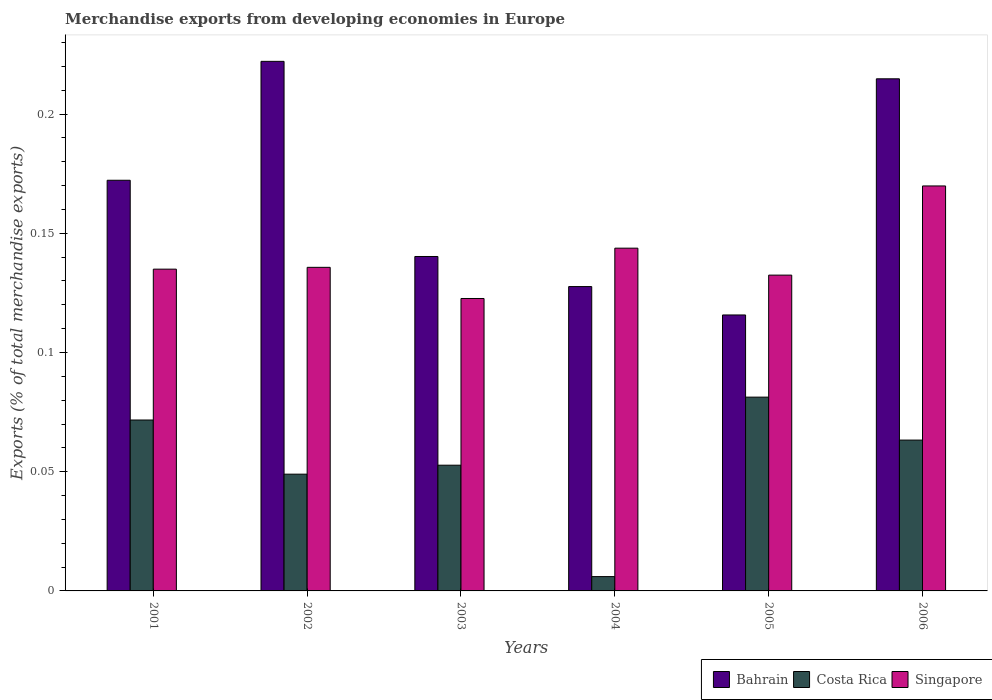How many different coloured bars are there?
Provide a succinct answer. 3. What is the label of the 5th group of bars from the left?
Provide a succinct answer. 2005. In how many cases, is the number of bars for a given year not equal to the number of legend labels?
Ensure brevity in your answer.  0. What is the percentage of total merchandise exports in Costa Rica in 2003?
Give a very brief answer. 0.05. Across all years, what is the maximum percentage of total merchandise exports in Singapore?
Give a very brief answer. 0.17. Across all years, what is the minimum percentage of total merchandise exports in Singapore?
Your answer should be compact. 0.12. In which year was the percentage of total merchandise exports in Bahrain minimum?
Ensure brevity in your answer.  2005. What is the total percentage of total merchandise exports in Costa Rica in the graph?
Your response must be concise. 0.32. What is the difference between the percentage of total merchandise exports in Costa Rica in 2003 and that in 2006?
Ensure brevity in your answer.  -0.01. What is the difference between the percentage of total merchandise exports in Costa Rica in 2005 and the percentage of total merchandise exports in Bahrain in 2004?
Provide a short and direct response. -0.05. What is the average percentage of total merchandise exports in Bahrain per year?
Provide a short and direct response. 0.17. In the year 2001, what is the difference between the percentage of total merchandise exports in Bahrain and percentage of total merchandise exports in Singapore?
Offer a terse response. 0.04. In how many years, is the percentage of total merchandise exports in Singapore greater than 0.05 %?
Offer a terse response. 6. What is the ratio of the percentage of total merchandise exports in Costa Rica in 2001 to that in 2006?
Provide a succinct answer. 1.13. Is the percentage of total merchandise exports in Bahrain in 2001 less than that in 2003?
Ensure brevity in your answer.  No. Is the difference between the percentage of total merchandise exports in Bahrain in 2003 and 2004 greater than the difference between the percentage of total merchandise exports in Singapore in 2003 and 2004?
Offer a very short reply. Yes. What is the difference between the highest and the second highest percentage of total merchandise exports in Costa Rica?
Offer a very short reply. 0.01. What is the difference between the highest and the lowest percentage of total merchandise exports in Costa Rica?
Ensure brevity in your answer.  0.08. Is the sum of the percentage of total merchandise exports in Costa Rica in 2003 and 2005 greater than the maximum percentage of total merchandise exports in Bahrain across all years?
Give a very brief answer. No. What does the 2nd bar from the left in 2003 represents?
Offer a very short reply. Costa Rica. What does the 2nd bar from the right in 2004 represents?
Your response must be concise. Costa Rica. Is it the case that in every year, the sum of the percentage of total merchandise exports in Bahrain and percentage of total merchandise exports in Singapore is greater than the percentage of total merchandise exports in Costa Rica?
Provide a short and direct response. Yes. How many bars are there?
Your response must be concise. 18. Are all the bars in the graph horizontal?
Keep it short and to the point. No. Does the graph contain any zero values?
Give a very brief answer. No. Where does the legend appear in the graph?
Your response must be concise. Bottom right. How many legend labels are there?
Ensure brevity in your answer.  3. What is the title of the graph?
Your response must be concise. Merchandise exports from developing economies in Europe. Does "Grenada" appear as one of the legend labels in the graph?
Your answer should be compact. No. What is the label or title of the X-axis?
Offer a terse response. Years. What is the label or title of the Y-axis?
Keep it short and to the point. Exports (% of total merchandise exports). What is the Exports (% of total merchandise exports) in Bahrain in 2001?
Make the answer very short. 0.17. What is the Exports (% of total merchandise exports) in Costa Rica in 2001?
Provide a succinct answer. 0.07. What is the Exports (% of total merchandise exports) of Singapore in 2001?
Provide a short and direct response. 0.13. What is the Exports (% of total merchandise exports) of Bahrain in 2002?
Your answer should be very brief. 0.22. What is the Exports (% of total merchandise exports) of Costa Rica in 2002?
Offer a terse response. 0.05. What is the Exports (% of total merchandise exports) in Singapore in 2002?
Offer a very short reply. 0.14. What is the Exports (% of total merchandise exports) in Bahrain in 2003?
Your response must be concise. 0.14. What is the Exports (% of total merchandise exports) in Costa Rica in 2003?
Offer a terse response. 0.05. What is the Exports (% of total merchandise exports) of Singapore in 2003?
Offer a terse response. 0.12. What is the Exports (% of total merchandise exports) in Bahrain in 2004?
Provide a succinct answer. 0.13. What is the Exports (% of total merchandise exports) of Costa Rica in 2004?
Ensure brevity in your answer.  0.01. What is the Exports (% of total merchandise exports) in Singapore in 2004?
Keep it short and to the point. 0.14. What is the Exports (% of total merchandise exports) in Bahrain in 2005?
Provide a short and direct response. 0.12. What is the Exports (% of total merchandise exports) of Costa Rica in 2005?
Your response must be concise. 0.08. What is the Exports (% of total merchandise exports) of Singapore in 2005?
Give a very brief answer. 0.13. What is the Exports (% of total merchandise exports) of Bahrain in 2006?
Keep it short and to the point. 0.21. What is the Exports (% of total merchandise exports) in Costa Rica in 2006?
Provide a short and direct response. 0.06. What is the Exports (% of total merchandise exports) in Singapore in 2006?
Offer a terse response. 0.17. Across all years, what is the maximum Exports (% of total merchandise exports) of Bahrain?
Ensure brevity in your answer.  0.22. Across all years, what is the maximum Exports (% of total merchandise exports) in Costa Rica?
Provide a short and direct response. 0.08. Across all years, what is the maximum Exports (% of total merchandise exports) in Singapore?
Your answer should be compact. 0.17. Across all years, what is the minimum Exports (% of total merchandise exports) of Bahrain?
Provide a short and direct response. 0.12. Across all years, what is the minimum Exports (% of total merchandise exports) of Costa Rica?
Keep it short and to the point. 0.01. Across all years, what is the minimum Exports (% of total merchandise exports) in Singapore?
Give a very brief answer. 0.12. What is the total Exports (% of total merchandise exports) in Bahrain in the graph?
Your answer should be very brief. 0.99. What is the total Exports (% of total merchandise exports) in Costa Rica in the graph?
Give a very brief answer. 0.32. What is the total Exports (% of total merchandise exports) of Singapore in the graph?
Make the answer very short. 0.84. What is the difference between the Exports (% of total merchandise exports) of Bahrain in 2001 and that in 2002?
Make the answer very short. -0.05. What is the difference between the Exports (% of total merchandise exports) of Costa Rica in 2001 and that in 2002?
Keep it short and to the point. 0.02. What is the difference between the Exports (% of total merchandise exports) of Singapore in 2001 and that in 2002?
Ensure brevity in your answer.  -0. What is the difference between the Exports (% of total merchandise exports) of Bahrain in 2001 and that in 2003?
Your answer should be very brief. 0.03. What is the difference between the Exports (% of total merchandise exports) of Costa Rica in 2001 and that in 2003?
Your answer should be very brief. 0.02. What is the difference between the Exports (% of total merchandise exports) in Singapore in 2001 and that in 2003?
Ensure brevity in your answer.  0.01. What is the difference between the Exports (% of total merchandise exports) in Bahrain in 2001 and that in 2004?
Give a very brief answer. 0.04. What is the difference between the Exports (% of total merchandise exports) of Costa Rica in 2001 and that in 2004?
Offer a terse response. 0.07. What is the difference between the Exports (% of total merchandise exports) in Singapore in 2001 and that in 2004?
Ensure brevity in your answer.  -0.01. What is the difference between the Exports (% of total merchandise exports) in Bahrain in 2001 and that in 2005?
Make the answer very short. 0.06. What is the difference between the Exports (% of total merchandise exports) in Costa Rica in 2001 and that in 2005?
Make the answer very short. -0.01. What is the difference between the Exports (% of total merchandise exports) in Singapore in 2001 and that in 2005?
Your response must be concise. 0. What is the difference between the Exports (% of total merchandise exports) in Bahrain in 2001 and that in 2006?
Give a very brief answer. -0.04. What is the difference between the Exports (% of total merchandise exports) of Costa Rica in 2001 and that in 2006?
Make the answer very short. 0.01. What is the difference between the Exports (% of total merchandise exports) of Singapore in 2001 and that in 2006?
Your answer should be compact. -0.03. What is the difference between the Exports (% of total merchandise exports) in Bahrain in 2002 and that in 2003?
Your answer should be very brief. 0.08. What is the difference between the Exports (% of total merchandise exports) of Costa Rica in 2002 and that in 2003?
Ensure brevity in your answer.  -0. What is the difference between the Exports (% of total merchandise exports) in Singapore in 2002 and that in 2003?
Your answer should be compact. 0.01. What is the difference between the Exports (% of total merchandise exports) in Bahrain in 2002 and that in 2004?
Your answer should be compact. 0.09. What is the difference between the Exports (% of total merchandise exports) of Costa Rica in 2002 and that in 2004?
Offer a very short reply. 0.04. What is the difference between the Exports (% of total merchandise exports) in Singapore in 2002 and that in 2004?
Ensure brevity in your answer.  -0.01. What is the difference between the Exports (% of total merchandise exports) of Bahrain in 2002 and that in 2005?
Your answer should be very brief. 0.11. What is the difference between the Exports (% of total merchandise exports) of Costa Rica in 2002 and that in 2005?
Your answer should be compact. -0.03. What is the difference between the Exports (% of total merchandise exports) of Singapore in 2002 and that in 2005?
Keep it short and to the point. 0. What is the difference between the Exports (% of total merchandise exports) in Bahrain in 2002 and that in 2006?
Your answer should be very brief. 0.01. What is the difference between the Exports (% of total merchandise exports) of Costa Rica in 2002 and that in 2006?
Make the answer very short. -0.01. What is the difference between the Exports (% of total merchandise exports) in Singapore in 2002 and that in 2006?
Provide a succinct answer. -0.03. What is the difference between the Exports (% of total merchandise exports) in Bahrain in 2003 and that in 2004?
Your answer should be very brief. 0.01. What is the difference between the Exports (% of total merchandise exports) of Costa Rica in 2003 and that in 2004?
Offer a terse response. 0.05. What is the difference between the Exports (% of total merchandise exports) of Singapore in 2003 and that in 2004?
Your answer should be very brief. -0.02. What is the difference between the Exports (% of total merchandise exports) of Bahrain in 2003 and that in 2005?
Provide a short and direct response. 0.02. What is the difference between the Exports (% of total merchandise exports) of Costa Rica in 2003 and that in 2005?
Your answer should be very brief. -0.03. What is the difference between the Exports (% of total merchandise exports) of Singapore in 2003 and that in 2005?
Ensure brevity in your answer.  -0.01. What is the difference between the Exports (% of total merchandise exports) of Bahrain in 2003 and that in 2006?
Give a very brief answer. -0.07. What is the difference between the Exports (% of total merchandise exports) in Costa Rica in 2003 and that in 2006?
Provide a short and direct response. -0.01. What is the difference between the Exports (% of total merchandise exports) in Singapore in 2003 and that in 2006?
Keep it short and to the point. -0.05. What is the difference between the Exports (% of total merchandise exports) of Bahrain in 2004 and that in 2005?
Provide a short and direct response. 0.01. What is the difference between the Exports (% of total merchandise exports) of Costa Rica in 2004 and that in 2005?
Provide a succinct answer. -0.08. What is the difference between the Exports (% of total merchandise exports) of Singapore in 2004 and that in 2005?
Provide a short and direct response. 0.01. What is the difference between the Exports (% of total merchandise exports) of Bahrain in 2004 and that in 2006?
Your answer should be very brief. -0.09. What is the difference between the Exports (% of total merchandise exports) in Costa Rica in 2004 and that in 2006?
Your answer should be very brief. -0.06. What is the difference between the Exports (% of total merchandise exports) of Singapore in 2004 and that in 2006?
Your answer should be very brief. -0.03. What is the difference between the Exports (% of total merchandise exports) in Bahrain in 2005 and that in 2006?
Ensure brevity in your answer.  -0.1. What is the difference between the Exports (% of total merchandise exports) in Costa Rica in 2005 and that in 2006?
Provide a short and direct response. 0.02. What is the difference between the Exports (% of total merchandise exports) in Singapore in 2005 and that in 2006?
Your response must be concise. -0.04. What is the difference between the Exports (% of total merchandise exports) in Bahrain in 2001 and the Exports (% of total merchandise exports) in Costa Rica in 2002?
Your response must be concise. 0.12. What is the difference between the Exports (% of total merchandise exports) in Bahrain in 2001 and the Exports (% of total merchandise exports) in Singapore in 2002?
Ensure brevity in your answer.  0.04. What is the difference between the Exports (% of total merchandise exports) in Costa Rica in 2001 and the Exports (% of total merchandise exports) in Singapore in 2002?
Your answer should be very brief. -0.06. What is the difference between the Exports (% of total merchandise exports) in Bahrain in 2001 and the Exports (% of total merchandise exports) in Costa Rica in 2003?
Your answer should be very brief. 0.12. What is the difference between the Exports (% of total merchandise exports) in Bahrain in 2001 and the Exports (% of total merchandise exports) in Singapore in 2003?
Give a very brief answer. 0.05. What is the difference between the Exports (% of total merchandise exports) in Costa Rica in 2001 and the Exports (% of total merchandise exports) in Singapore in 2003?
Give a very brief answer. -0.05. What is the difference between the Exports (% of total merchandise exports) of Bahrain in 2001 and the Exports (% of total merchandise exports) of Costa Rica in 2004?
Ensure brevity in your answer.  0.17. What is the difference between the Exports (% of total merchandise exports) of Bahrain in 2001 and the Exports (% of total merchandise exports) of Singapore in 2004?
Your answer should be compact. 0.03. What is the difference between the Exports (% of total merchandise exports) of Costa Rica in 2001 and the Exports (% of total merchandise exports) of Singapore in 2004?
Your answer should be compact. -0.07. What is the difference between the Exports (% of total merchandise exports) in Bahrain in 2001 and the Exports (% of total merchandise exports) in Costa Rica in 2005?
Your answer should be very brief. 0.09. What is the difference between the Exports (% of total merchandise exports) of Bahrain in 2001 and the Exports (% of total merchandise exports) of Singapore in 2005?
Make the answer very short. 0.04. What is the difference between the Exports (% of total merchandise exports) of Costa Rica in 2001 and the Exports (% of total merchandise exports) of Singapore in 2005?
Your answer should be very brief. -0.06. What is the difference between the Exports (% of total merchandise exports) of Bahrain in 2001 and the Exports (% of total merchandise exports) of Costa Rica in 2006?
Offer a very short reply. 0.11. What is the difference between the Exports (% of total merchandise exports) in Bahrain in 2001 and the Exports (% of total merchandise exports) in Singapore in 2006?
Make the answer very short. 0. What is the difference between the Exports (% of total merchandise exports) of Costa Rica in 2001 and the Exports (% of total merchandise exports) of Singapore in 2006?
Make the answer very short. -0.1. What is the difference between the Exports (% of total merchandise exports) in Bahrain in 2002 and the Exports (% of total merchandise exports) in Costa Rica in 2003?
Your answer should be compact. 0.17. What is the difference between the Exports (% of total merchandise exports) in Bahrain in 2002 and the Exports (% of total merchandise exports) in Singapore in 2003?
Make the answer very short. 0.1. What is the difference between the Exports (% of total merchandise exports) in Costa Rica in 2002 and the Exports (% of total merchandise exports) in Singapore in 2003?
Keep it short and to the point. -0.07. What is the difference between the Exports (% of total merchandise exports) in Bahrain in 2002 and the Exports (% of total merchandise exports) in Costa Rica in 2004?
Ensure brevity in your answer.  0.22. What is the difference between the Exports (% of total merchandise exports) in Bahrain in 2002 and the Exports (% of total merchandise exports) in Singapore in 2004?
Ensure brevity in your answer.  0.08. What is the difference between the Exports (% of total merchandise exports) of Costa Rica in 2002 and the Exports (% of total merchandise exports) of Singapore in 2004?
Your response must be concise. -0.09. What is the difference between the Exports (% of total merchandise exports) of Bahrain in 2002 and the Exports (% of total merchandise exports) of Costa Rica in 2005?
Your answer should be compact. 0.14. What is the difference between the Exports (% of total merchandise exports) in Bahrain in 2002 and the Exports (% of total merchandise exports) in Singapore in 2005?
Ensure brevity in your answer.  0.09. What is the difference between the Exports (% of total merchandise exports) of Costa Rica in 2002 and the Exports (% of total merchandise exports) of Singapore in 2005?
Keep it short and to the point. -0.08. What is the difference between the Exports (% of total merchandise exports) of Bahrain in 2002 and the Exports (% of total merchandise exports) of Costa Rica in 2006?
Give a very brief answer. 0.16. What is the difference between the Exports (% of total merchandise exports) in Bahrain in 2002 and the Exports (% of total merchandise exports) in Singapore in 2006?
Your response must be concise. 0.05. What is the difference between the Exports (% of total merchandise exports) in Costa Rica in 2002 and the Exports (% of total merchandise exports) in Singapore in 2006?
Provide a short and direct response. -0.12. What is the difference between the Exports (% of total merchandise exports) in Bahrain in 2003 and the Exports (% of total merchandise exports) in Costa Rica in 2004?
Your response must be concise. 0.13. What is the difference between the Exports (% of total merchandise exports) of Bahrain in 2003 and the Exports (% of total merchandise exports) of Singapore in 2004?
Offer a terse response. -0. What is the difference between the Exports (% of total merchandise exports) of Costa Rica in 2003 and the Exports (% of total merchandise exports) of Singapore in 2004?
Your answer should be compact. -0.09. What is the difference between the Exports (% of total merchandise exports) of Bahrain in 2003 and the Exports (% of total merchandise exports) of Costa Rica in 2005?
Keep it short and to the point. 0.06. What is the difference between the Exports (% of total merchandise exports) of Bahrain in 2003 and the Exports (% of total merchandise exports) of Singapore in 2005?
Make the answer very short. 0.01. What is the difference between the Exports (% of total merchandise exports) of Costa Rica in 2003 and the Exports (% of total merchandise exports) of Singapore in 2005?
Keep it short and to the point. -0.08. What is the difference between the Exports (% of total merchandise exports) in Bahrain in 2003 and the Exports (% of total merchandise exports) in Costa Rica in 2006?
Provide a short and direct response. 0.08. What is the difference between the Exports (% of total merchandise exports) of Bahrain in 2003 and the Exports (% of total merchandise exports) of Singapore in 2006?
Make the answer very short. -0.03. What is the difference between the Exports (% of total merchandise exports) in Costa Rica in 2003 and the Exports (% of total merchandise exports) in Singapore in 2006?
Your answer should be very brief. -0.12. What is the difference between the Exports (% of total merchandise exports) in Bahrain in 2004 and the Exports (% of total merchandise exports) in Costa Rica in 2005?
Your answer should be very brief. 0.05. What is the difference between the Exports (% of total merchandise exports) in Bahrain in 2004 and the Exports (% of total merchandise exports) in Singapore in 2005?
Ensure brevity in your answer.  -0. What is the difference between the Exports (% of total merchandise exports) in Costa Rica in 2004 and the Exports (% of total merchandise exports) in Singapore in 2005?
Your response must be concise. -0.13. What is the difference between the Exports (% of total merchandise exports) of Bahrain in 2004 and the Exports (% of total merchandise exports) of Costa Rica in 2006?
Your response must be concise. 0.06. What is the difference between the Exports (% of total merchandise exports) in Bahrain in 2004 and the Exports (% of total merchandise exports) in Singapore in 2006?
Give a very brief answer. -0.04. What is the difference between the Exports (% of total merchandise exports) of Costa Rica in 2004 and the Exports (% of total merchandise exports) of Singapore in 2006?
Make the answer very short. -0.16. What is the difference between the Exports (% of total merchandise exports) of Bahrain in 2005 and the Exports (% of total merchandise exports) of Costa Rica in 2006?
Your response must be concise. 0.05. What is the difference between the Exports (% of total merchandise exports) in Bahrain in 2005 and the Exports (% of total merchandise exports) in Singapore in 2006?
Ensure brevity in your answer.  -0.05. What is the difference between the Exports (% of total merchandise exports) of Costa Rica in 2005 and the Exports (% of total merchandise exports) of Singapore in 2006?
Keep it short and to the point. -0.09. What is the average Exports (% of total merchandise exports) in Bahrain per year?
Provide a short and direct response. 0.17. What is the average Exports (% of total merchandise exports) in Costa Rica per year?
Your response must be concise. 0.05. What is the average Exports (% of total merchandise exports) in Singapore per year?
Provide a succinct answer. 0.14. In the year 2001, what is the difference between the Exports (% of total merchandise exports) of Bahrain and Exports (% of total merchandise exports) of Costa Rica?
Provide a short and direct response. 0.1. In the year 2001, what is the difference between the Exports (% of total merchandise exports) in Bahrain and Exports (% of total merchandise exports) in Singapore?
Offer a terse response. 0.04. In the year 2001, what is the difference between the Exports (% of total merchandise exports) of Costa Rica and Exports (% of total merchandise exports) of Singapore?
Offer a very short reply. -0.06. In the year 2002, what is the difference between the Exports (% of total merchandise exports) of Bahrain and Exports (% of total merchandise exports) of Costa Rica?
Give a very brief answer. 0.17. In the year 2002, what is the difference between the Exports (% of total merchandise exports) in Bahrain and Exports (% of total merchandise exports) in Singapore?
Offer a very short reply. 0.09. In the year 2002, what is the difference between the Exports (% of total merchandise exports) in Costa Rica and Exports (% of total merchandise exports) in Singapore?
Give a very brief answer. -0.09. In the year 2003, what is the difference between the Exports (% of total merchandise exports) of Bahrain and Exports (% of total merchandise exports) of Costa Rica?
Make the answer very short. 0.09. In the year 2003, what is the difference between the Exports (% of total merchandise exports) in Bahrain and Exports (% of total merchandise exports) in Singapore?
Give a very brief answer. 0.02. In the year 2003, what is the difference between the Exports (% of total merchandise exports) in Costa Rica and Exports (% of total merchandise exports) in Singapore?
Your response must be concise. -0.07. In the year 2004, what is the difference between the Exports (% of total merchandise exports) of Bahrain and Exports (% of total merchandise exports) of Costa Rica?
Provide a succinct answer. 0.12. In the year 2004, what is the difference between the Exports (% of total merchandise exports) in Bahrain and Exports (% of total merchandise exports) in Singapore?
Keep it short and to the point. -0.02. In the year 2004, what is the difference between the Exports (% of total merchandise exports) in Costa Rica and Exports (% of total merchandise exports) in Singapore?
Give a very brief answer. -0.14. In the year 2005, what is the difference between the Exports (% of total merchandise exports) of Bahrain and Exports (% of total merchandise exports) of Costa Rica?
Provide a succinct answer. 0.03. In the year 2005, what is the difference between the Exports (% of total merchandise exports) of Bahrain and Exports (% of total merchandise exports) of Singapore?
Your answer should be very brief. -0.02. In the year 2005, what is the difference between the Exports (% of total merchandise exports) in Costa Rica and Exports (% of total merchandise exports) in Singapore?
Provide a short and direct response. -0.05. In the year 2006, what is the difference between the Exports (% of total merchandise exports) in Bahrain and Exports (% of total merchandise exports) in Costa Rica?
Your answer should be very brief. 0.15. In the year 2006, what is the difference between the Exports (% of total merchandise exports) of Bahrain and Exports (% of total merchandise exports) of Singapore?
Your response must be concise. 0.04. In the year 2006, what is the difference between the Exports (% of total merchandise exports) of Costa Rica and Exports (% of total merchandise exports) of Singapore?
Provide a succinct answer. -0.11. What is the ratio of the Exports (% of total merchandise exports) of Bahrain in 2001 to that in 2002?
Your answer should be very brief. 0.78. What is the ratio of the Exports (% of total merchandise exports) in Costa Rica in 2001 to that in 2002?
Offer a terse response. 1.46. What is the ratio of the Exports (% of total merchandise exports) in Bahrain in 2001 to that in 2003?
Offer a very short reply. 1.23. What is the ratio of the Exports (% of total merchandise exports) in Costa Rica in 2001 to that in 2003?
Make the answer very short. 1.36. What is the ratio of the Exports (% of total merchandise exports) in Singapore in 2001 to that in 2003?
Your answer should be compact. 1.1. What is the ratio of the Exports (% of total merchandise exports) in Bahrain in 2001 to that in 2004?
Keep it short and to the point. 1.35. What is the ratio of the Exports (% of total merchandise exports) of Costa Rica in 2001 to that in 2004?
Your answer should be compact. 11.93. What is the ratio of the Exports (% of total merchandise exports) of Singapore in 2001 to that in 2004?
Give a very brief answer. 0.94. What is the ratio of the Exports (% of total merchandise exports) in Bahrain in 2001 to that in 2005?
Offer a terse response. 1.49. What is the ratio of the Exports (% of total merchandise exports) in Costa Rica in 2001 to that in 2005?
Keep it short and to the point. 0.88. What is the ratio of the Exports (% of total merchandise exports) of Singapore in 2001 to that in 2005?
Offer a terse response. 1.02. What is the ratio of the Exports (% of total merchandise exports) of Bahrain in 2001 to that in 2006?
Your answer should be compact. 0.8. What is the ratio of the Exports (% of total merchandise exports) of Costa Rica in 2001 to that in 2006?
Ensure brevity in your answer.  1.13. What is the ratio of the Exports (% of total merchandise exports) in Singapore in 2001 to that in 2006?
Your response must be concise. 0.79. What is the ratio of the Exports (% of total merchandise exports) in Bahrain in 2002 to that in 2003?
Offer a terse response. 1.58. What is the ratio of the Exports (% of total merchandise exports) of Costa Rica in 2002 to that in 2003?
Your response must be concise. 0.93. What is the ratio of the Exports (% of total merchandise exports) of Singapore in 2002 to that in 2003?
Keep it short and to the point. 1.11. What is the ratio of the Exports (% of total merchandise exports) of Bahrain in 2002 to that in 2004?
Provide a short and direct response. 1.74. What is the ratio of the Exports (% of total merchandise exports) of Costa Rica in 2002 to that in 2004?
Provide a short and direct response. 8.15. What is the ratio of the Exports (% of total merchandise exports) of Singapore in 2002 to that in 2004?
Make the answer very short. 0.94. What is the ratio of the Exports (% of total merchandise exports) of Bahrain in 2002 to that in 2005?
Provide a short and direct response. 1.92. What is the ratio of the Exports (% of total merchandise exports) in Costa Rica in 2002 to that in 2005?
Ensure brevity in your answer.  0.6. What is the ratio of the Exports (% of total merchandise exports) in Singapore in 2002 to that in 2005?
Keep it short and to the point. 1.02. What is the ratio of the Exports (% of total merchandise exports) of Bahrain in 2002 to that in 2006?
Your response must be concise. 1.03. What is the ratio of the Exports (% of total merchandise exports) in Costa Rica in 2002 to that in 2006?
Your response must be concise. 0.77. What is the ratio of the Exports (% of total merchandise exports) in Singapore in 2002 to that in 2006?
Make the answer very short. 0.8. What is the ratio of the Exports (% of total merchandise exports) in Bahrain in 2003 to that in 2004?
Offer a terse response. 1.1. What is the ratio of the Exports (% of total merchandise exports) of Costa Rica in 2003 to that in 2004?
Your response must be concise. 8.78. What is the ratio of the Exports (% of total merchandise exports) in Singapore in 2003 to that in 2004?
Give a very brief answer. 0.85. What is the ratio of the Exports (% of total merchandise exports) of Bahrain in 2003 to that in 2005?
Offer a terse response. 1.21. What is the ratio of the Exports (% of total merchandise exports) of Costa Rica in 2003 to that in 2005?
Provide a short and direct response. 0.65. What is the ratio of the Exports (% of total merchandise exports) of Singapore in 2003 to that in 2005?
Offer a very short reply. 0.93. What is the ratio of the Exports (% of total merchandise exports) in Bahrain in 2003 to that in 2006?
Keep it short and to the point. 0.65. What is the ratio of the Exports (% of total merchandise exports) of Costa Rica in 2003 to that in 2006?
Give a very brief answer. 0.83. What is the ratio of the Exports (% of total merchandise exports) of Singapore in 2003 to that in 2006?
Your response must be concise. 0.72. What is the ratio of the Exports (% of total merchandise exports) of Bahrain in 2004 to that in 2005?
Make the answer very short. 1.1. What is the ratio of the Exports (% of total merchandise exports) of Costa Rica in 2004 to that in 2005?
Ensure brevity in your answer.  0.07. What is the ratio of the Exports (% of total merchandise exports) in Singapore in 2004 to that in 2005?
Offer a terse response. 1.09. What is the ratio of the Exports (% of total merchandise exports) in Bahrain in 2004 to that in 2006?
Ensure brevity in your answer.  0.59. What is the ratio of the Exports (% of total merchandise exports) of Costa Rica in 2004 to that in 2006?
Your answer should be compact. 0.1. What is the ratio of the Exports (% of total merchandise exports) in Singapore in 2004 to that in 2006?
Make the answer very short. 0.85. What is the ratio of the Exports (% of total merchandise exports) of Bahrain in 2005 to that in 2006?
Your answer should be very brief. 0.54. What is the ratio of the Exports (% of total merchandise exports) of Costa Rica in 2005 to that in 2006?
Keep it short and to the point. 1.28. What is the ratio of the Exports (% of total merchandise exports) in Singapore in 2005 to that in 2006?
Provide a succinct answer. 0.78. What is the difference between the highest and the second highest Exports (% of total merchandise exports) of Bahrain?
Provide a succinct answer. 0.01. What is the difference between the highest and the second highest Exports (% of total merchandise exports) in Costa Rica?
Provide a short and direct response. 0.01. What is the difference between the highest and the second highest Exports (% of total merchandise exports) of Singapore?
Provide a succinct answer. 0.03. What is the difference between the highest and the lowest Exports (% of total merchandise exports) of Bahrain?
Your answer should be very brief. 0.11. What is the difference between the highest and the lowest Exports (% of total merchandise exports) in Costa Rica?
Your response must be concise. 0.08. What is the difference between the highest and the lowest Exports (% of total merchandise exports) in Singapore?
Offer a very short reply. 0.05. 